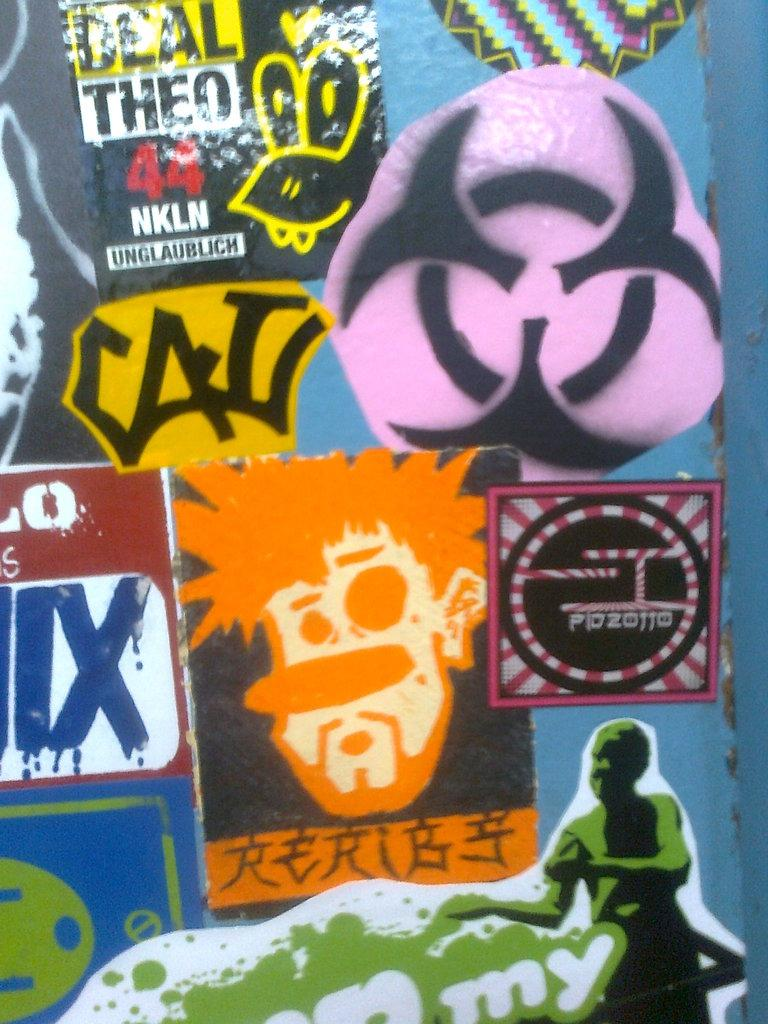<image>
Render a clear and concise summary of the photo. lots of colorful stickers including ones for Deal Theo 44 NKLN 